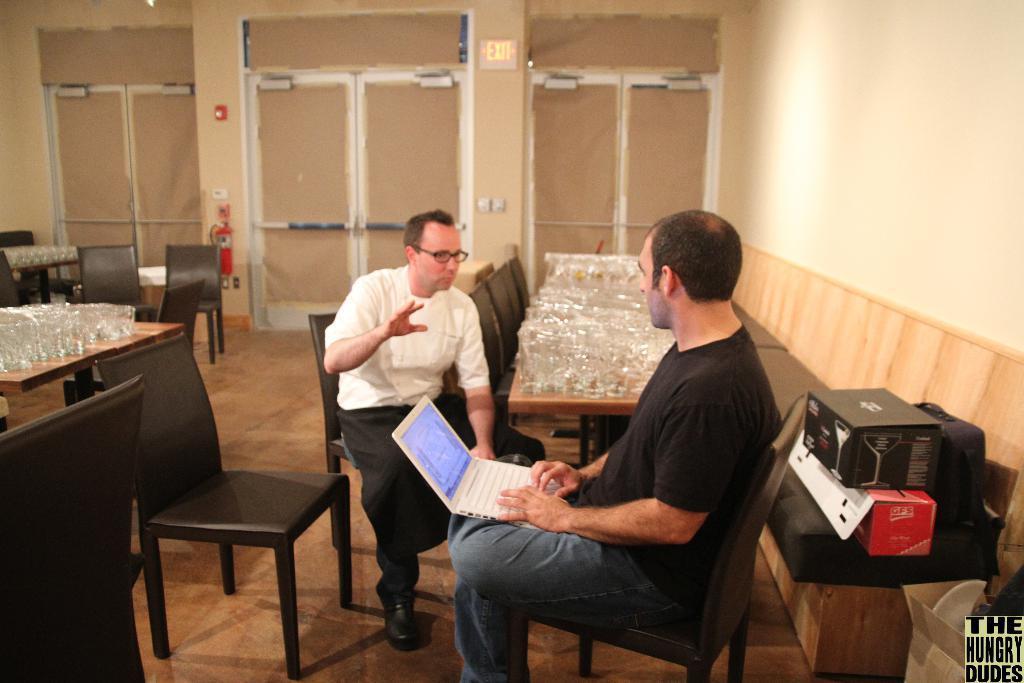Could you give a brief overview of what you see in this image? In this image we can see a man wearing black t-shirt is sitting on the chair and holding a laptop. We can see a man wearing white shirt is sitting on the chair. In the background we can see many glasses placed on the table, exit board and a fire extinguisher. 